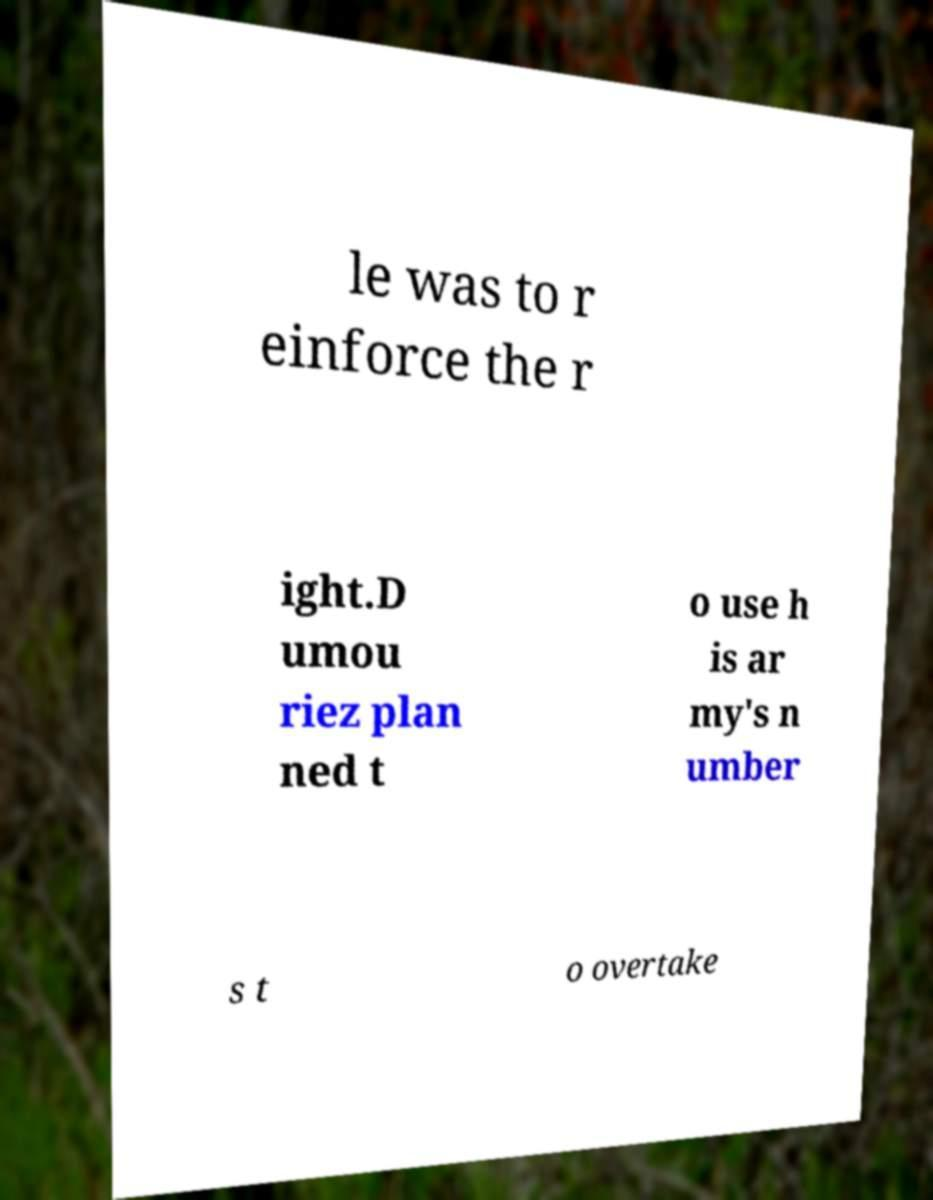Could you extract and type out the text from this image? le was to r einforce the r ight.D umou riez plan ned t o use h is ar my's n umber s t o overtake 